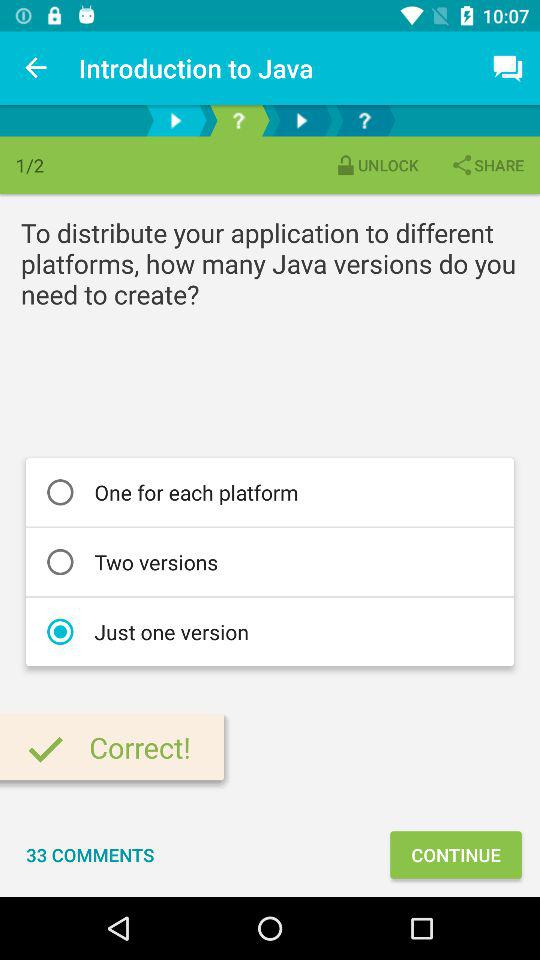Which page number are we currently on? You are currently on page number 1. 